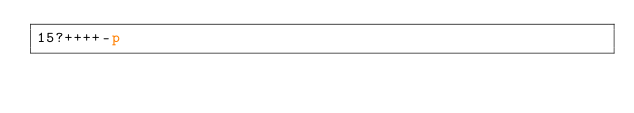<code> <loc_0><loc_0><loc_500><loc_500><_dc_>15?++++-p</code> 